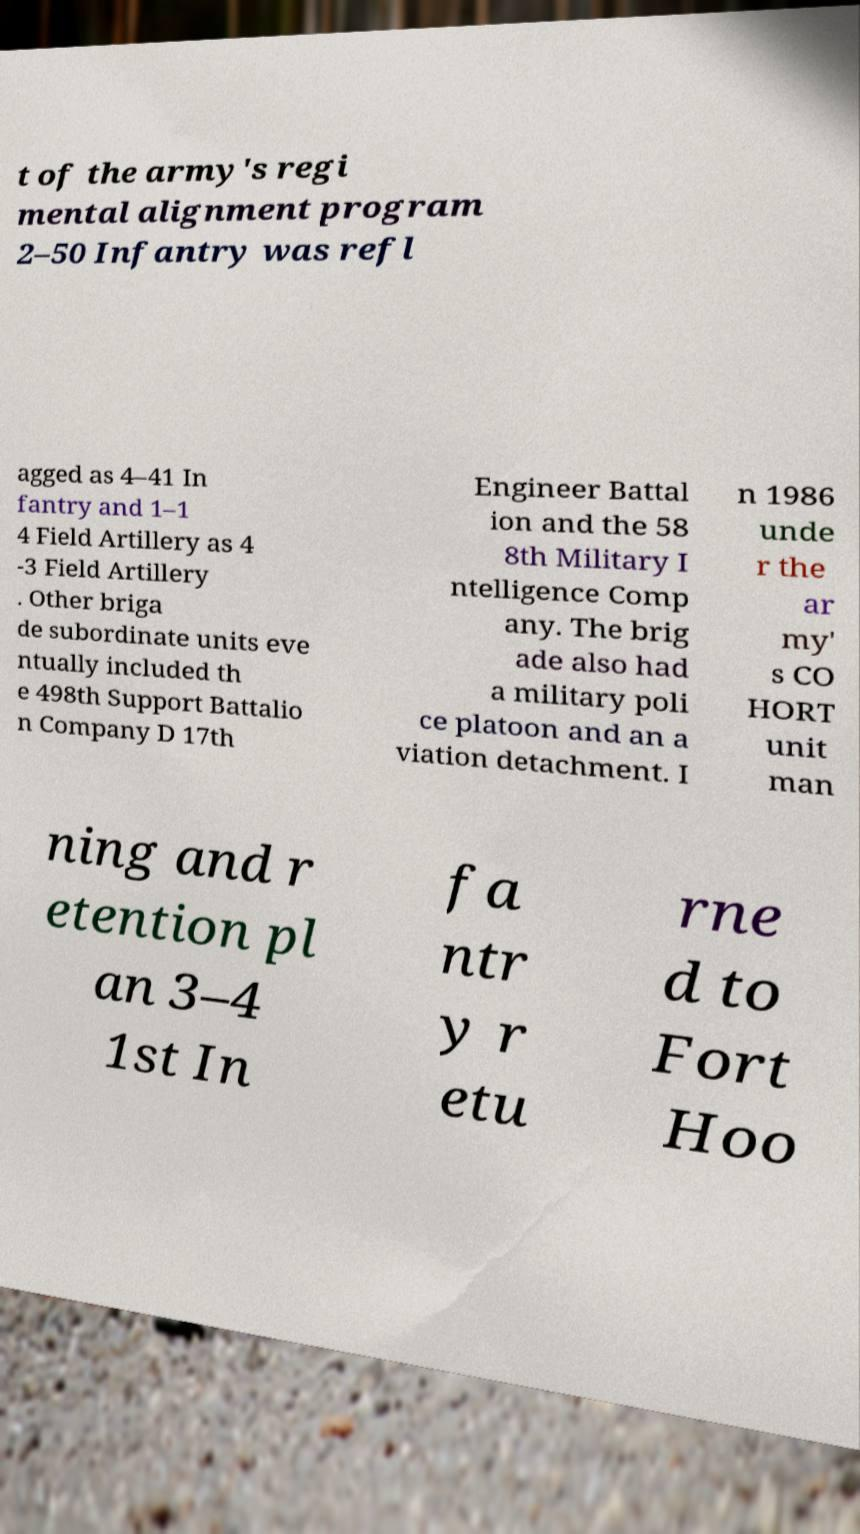Can you read and provide the text displayed in the image?This photo seems to have some interesting text. Can you extract and type it out for me? t of the army's regi mental alignment program 2–50 Infantry was refl agged as 4–41 In fantry and 1–1 4 Field Artillery as 4 -3 Field Artillery . Other briga de subordinate units eve ntually included th e 498th Support Battalio n Company D 17th Engineer Battal ion and the 58 8th Military I ntelligence Comp any. The brig ade also had a military poli ce platoon and an a viation detachment. I n 1986 unde r the ar my' s CO HORT unit man ning and r etention pl an 3–4 1st In fa ntr y r etu rne d to Fort Hoo 